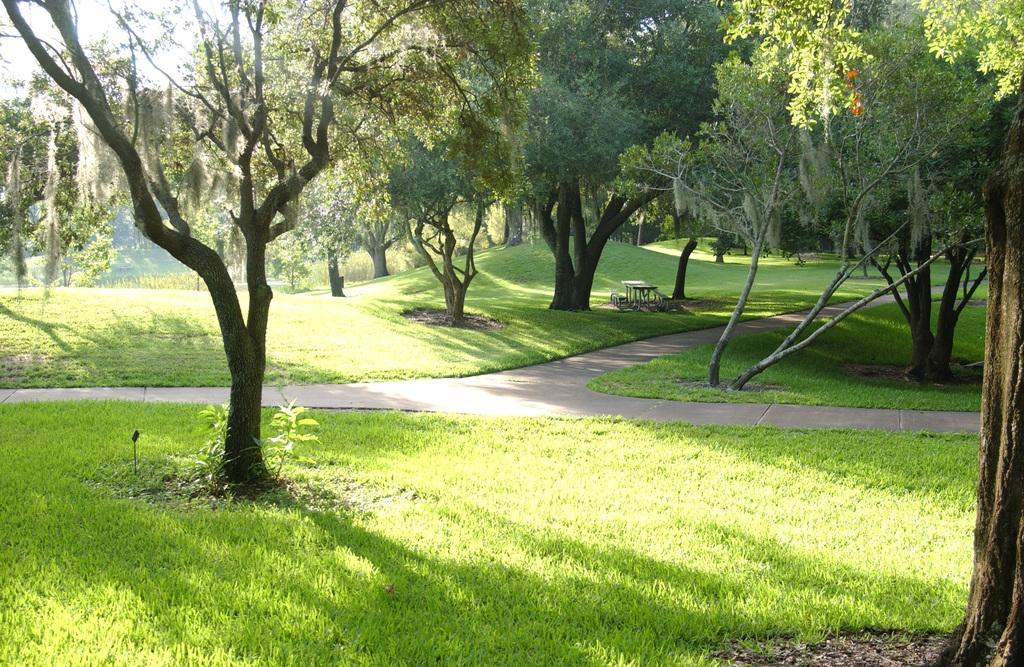What type of vegetation can be seen in the image? There are trees in the image. What object is on the ground in the image? There is a table on the ground in the image. How many fish can be seen swimming in the sky in the image? There are no fish visible in the image, and the sky is not mentioned in the provided facts. Additionally, fish cannot swim in the sky. 